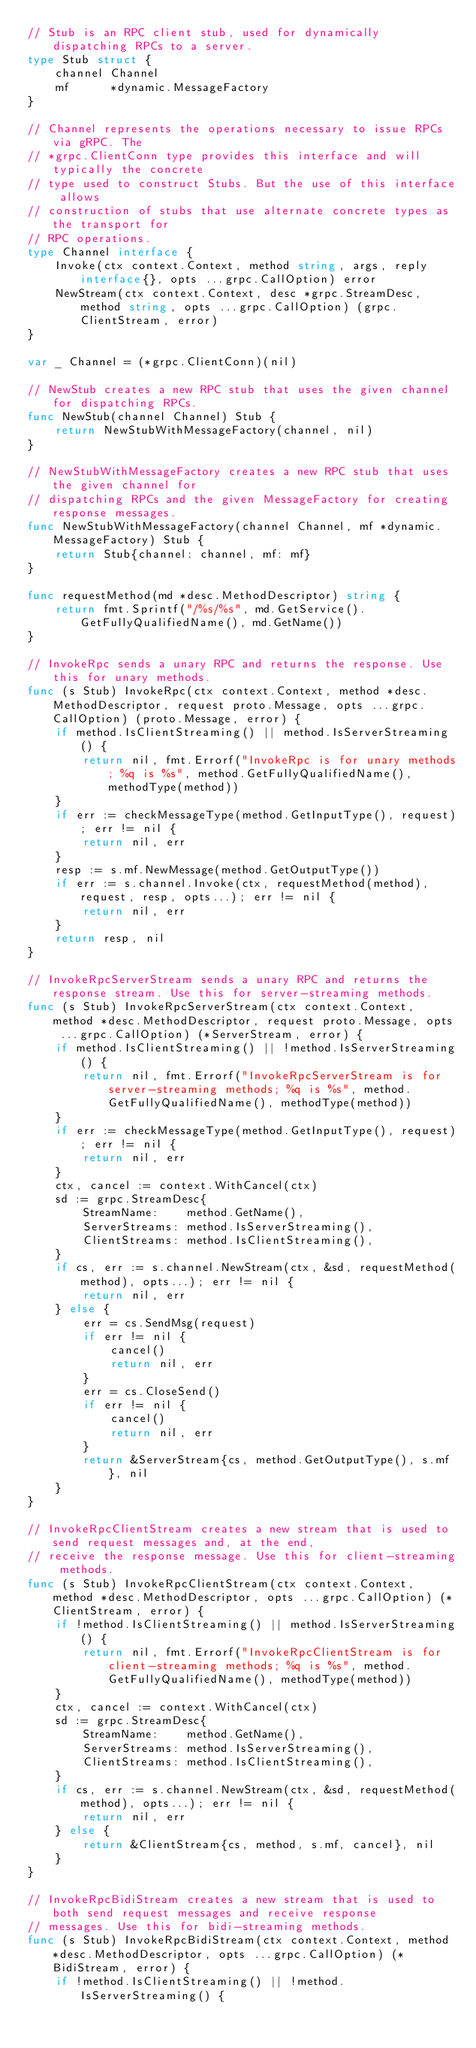<code> <loc_0><loc_0><loc_500><loc_500><_Go_>// Stub is an RPC client stub, used for dynamically dispatching RPCs to a server.
type Stub struct {
	channel Channel
	mf      *dynamic.MessageFactory
}

// Channel represents the operations necessary to issue RPCs via gRPC. The
// *grpc.ClientConn type provides this interface and will typically the concrete
// type used to construct Stubs. But the use of this interface allows
// construction of stubs that use alternate concrete types as the transport for
// RPC operations.
type Channel interface {
	Invoke(ctx context.Context, method string, args, reply interface{}, opts ...grpc.CallOption) error
	NewStream(ctx context.Context, desc *grpc.StreamDesc, method string, opts ...grpc.CallOption) (grpc.ClientStream, error)
}

var _ Channel = (*grpc.ClientConn)(nil)

// NewStub creates a new RPC stub that uses the given channel for dispatching RPCs.
func NewStub(channel Channel) Stub {
	return NewStubWithMessageFactory(channel, nil)
}

// NewStubWithMessageFactory creates a new RPC stub that uses the given channel for
// dispatching RPCs and the given MessageFactory for creating response messages.
func NewStubWithMessageFactory(channel Channel, mf *dynamic.MessageFactory) Stub {
	return Stub{channel: channel, mf: mf}
}

func requestMethod(md *desc.MethodDescriptor) string {
	return fmt.Sprintf("/%s/%s", md.GetService().GetFullyQualifiedName(), md.GetName())
}

// InvokeRpc sends a unary RPC and returns the response. Use this for unary methods.
func (s Stub) InvokeRpc(ctx context.Context, method *desc.MethodDescriptor, request proto.Message, opts ...grpc.CallOption) (proto.Message, error) {
	if method.IsClientStreaming() || method.IsServerStreaming() {
		return nil, fmt.Errorf("InvokeRpc is for unary methods; %q is %s", method.GetFullyQualifiedName(), methodType(method))
	}
	if err := checkMessageType(method.GetInputType(), request); err != nil {
		return nil, err
	}
	resp := s.mf.NewMessage(method.GetOutputType())
	if err := s.channel.Invoke(ctx, requestMethod(method), request, resp, opts...); err != nil {
		return nil, err
	}
	return resp, nil
}

// InvokeRpcServerStream sends a unary RPC and returns the response stream. Use this for server-streaming methods.
func (s Stub) InvokeRpcServerStream(ctx context.Context, method *desc.MethodDescriptor, request proto.Message, opts ...grpc.CallOption) (*ServerStream, error) {
	if method.IsClientStreaming() || !method.IsServerStreaming() {
		return nil, fmt.Errorf("InvokeRpcServerStream is for server-streaming methods; %q is %s", method.GetFullyQualifiedName(), methodType(method))
	}
	if err := checkMessageType(method.GetInputType(), request); err != nil {
		return nil, err
	}
	ctx, cancel := context.WithCancel(ctx)
	sd := grpc.StreamDesc{
		StreamName:    method.GetName(),
		ServerStreams: method.IsServerStreaming(),
		ClientStreams: method.IsClientStreaming(),
	}
	if cs, err := s.channel.NewStream(ctx, &sd, requestMethod(method), opts...); err != nil {
		return nil, err
	} else {
		err = cs.SendMsg(request)
		if err != nil {
			cancel()
			return nil, err
		}
		err = cs.CloseSend()
		if err != nil {
			cancel()
			return nil, err
		}
		return &ServerStream{cs, method.GetOutputType(), s.mf}, nil
	}
}

// InvokeRpcClientStream creates a new stream that is used to send request messages and, at the end,
// receive the response message. Use this for client-streaming methods.
func (s Stub) InvokeRpcClientStream(ctx context.Context, method *desc.MethodDescriptor, opts ...grpc.CallOption) (*ClientStream, error) {
	if !method.IsClientStreaming() || method.IsServerStreaming() {
		return nil, fmt.Errorf("InvokeRpcClientStream is for client-streaming methods; %q is %s", method.GetFullyQualifiedName(), methodType(method))
	}
	ctx, cancel := context.WithCancel(ctx)
	sd := grpc.StreamDesc{
		StreamName:    method.GetName(),
		ServerStreams: method.IsServerStreaming(),
		ClientStreams: method.IsClientStreaming(),
	}
	if cs, err := s.channel.NewStream(ctx, &sd, requestMethod(method), opts...); err != nil {
		return nil, err
	} else {
		return &ClientStream{cs, method, s.mf, cancel}, nil
	}
}

// InvokeRpcBidiStream creates a new stream that is used to both send request messages and receive response
// messages. Use this for bidi-streaming methods.
func (s Stub) InvokeRpcBidiStream(ctx context.Context, method *desc.MethodDescriptor, opts ...grpc.CallOption) (*BidiStream, error) {
	if !method.IsClientStreaming() || !method.IsServerStreaming() {</code> 